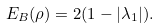Convert formula to latex. <formula><loc_0><loc_0><loc_500><loc_500>E _ { B } ( \rho ) = 2 ( 1 - | \lambda _ { 1 } | ) .</formula> 